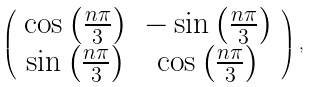<formula> <loc_0><loc_0><loc_500><loc_500>\left ( \begin{array} { c c } \cos { \left ( \frac { n \pi } { 3 } \right ) } & - \sin { \left ( \frac { n \pi } { 3 } \right ) } \\ \sin { \left ( \frac { n \pi } { 3 } \right ) } & \cos { \left ( \frac { n \pi } { 3 } \right ) } \end{array} \right ) ,</formula> 